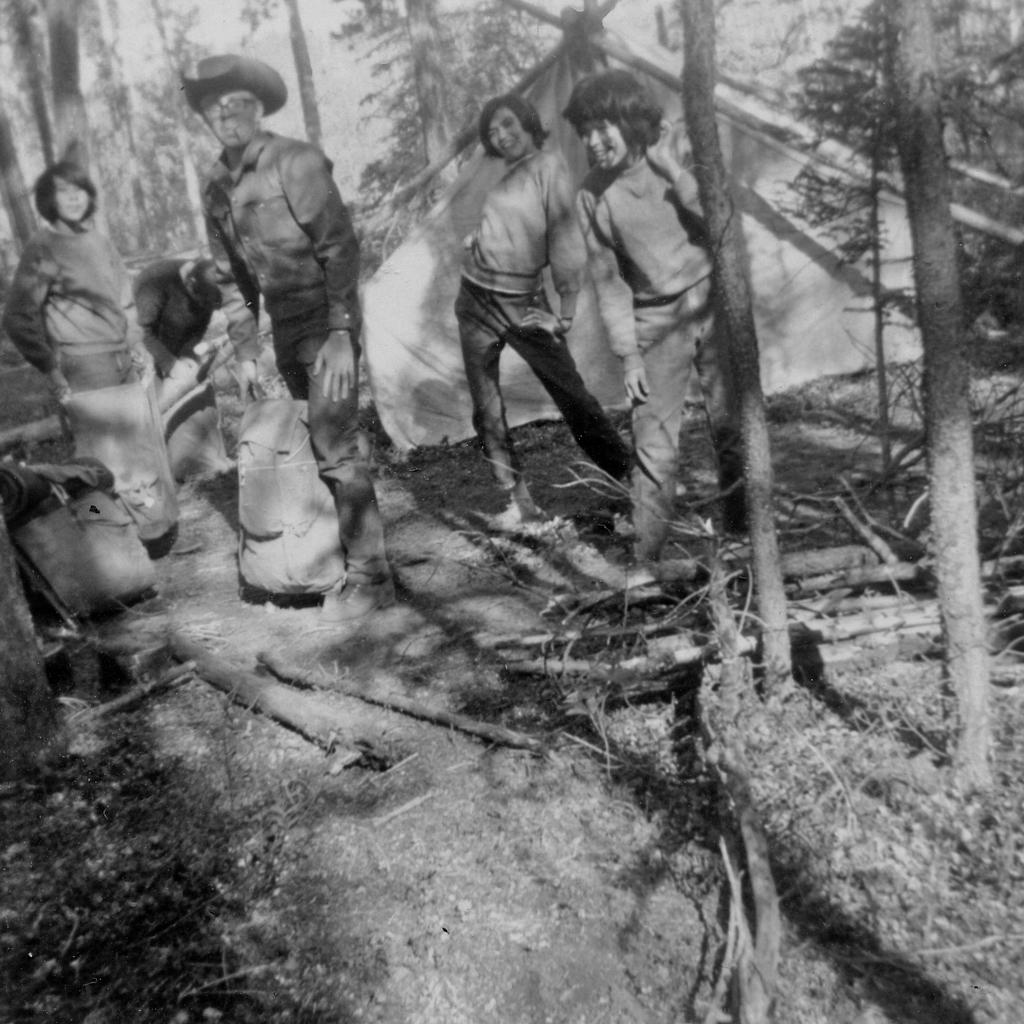Who or what can be seen in the image? There are people in the image. What type of natural elements are present in the image? There are trees in the image. What objects are visible in the image that could be used for various purposes? There are sticks in the image. What type of shelter is present in the image? There is a tent in the image. What can be found on the ground in the image? There are objects on the ground in the image. How is the image presented in terms of color? The image is in black and white. What type of chin can be seen on the person in the image? There is no chin visible in the image, as it is in black and white and does not show any facial features. What type of home is depicted in the image? There is no home depicted in the image; it features people, trees, sticks, a tent, and objects on the ground. What type of umbrella is being used by the person in the image? There is no umbrella present in the image. 